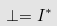Convert formula to latex. <formula><loc_0><loc_0><loc_500><loc_500>\perp = I ^ { * }</formula> 